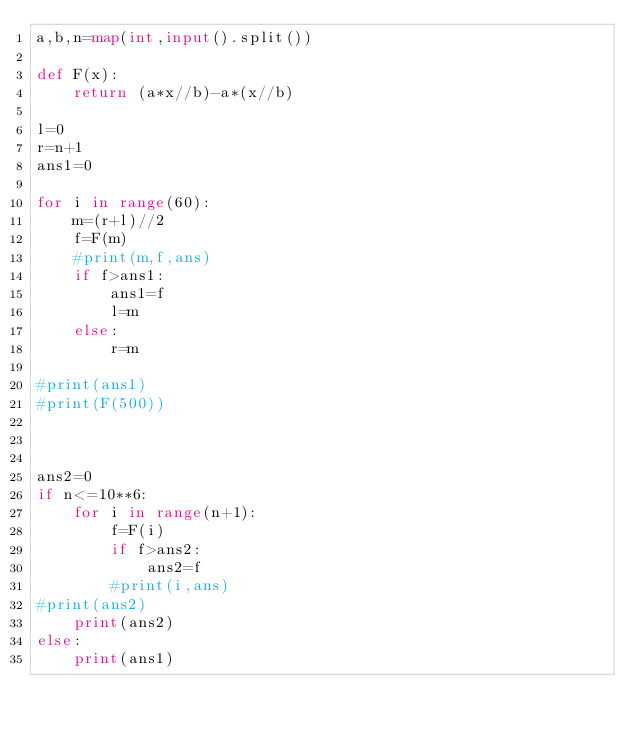Convert code to text. <code><loc_0><loc_0><loc_500><loc_500><_Python_>a,b,n=map(int,input().split())

def F(x):
    return (a*x//b)-a*(x//b)

l=0
r=n+1
ans1=0

for i in range(60):
    m=(r+l)//2
    f=F(m)
    #print(m,f,ans)
    if f>ans1:
        ans1=f
        l=m
    else:
        r=m
    
#print(ans1)
#print(F(500))



ans2=0
if n<=10**6:
    for i in range(n+1):
        f=F(i)
        if f>ans2:
            ans2=f
        #print(i,ans)
#print(ans2)
    print(ans2)
else:
    print(ans1)</code> 